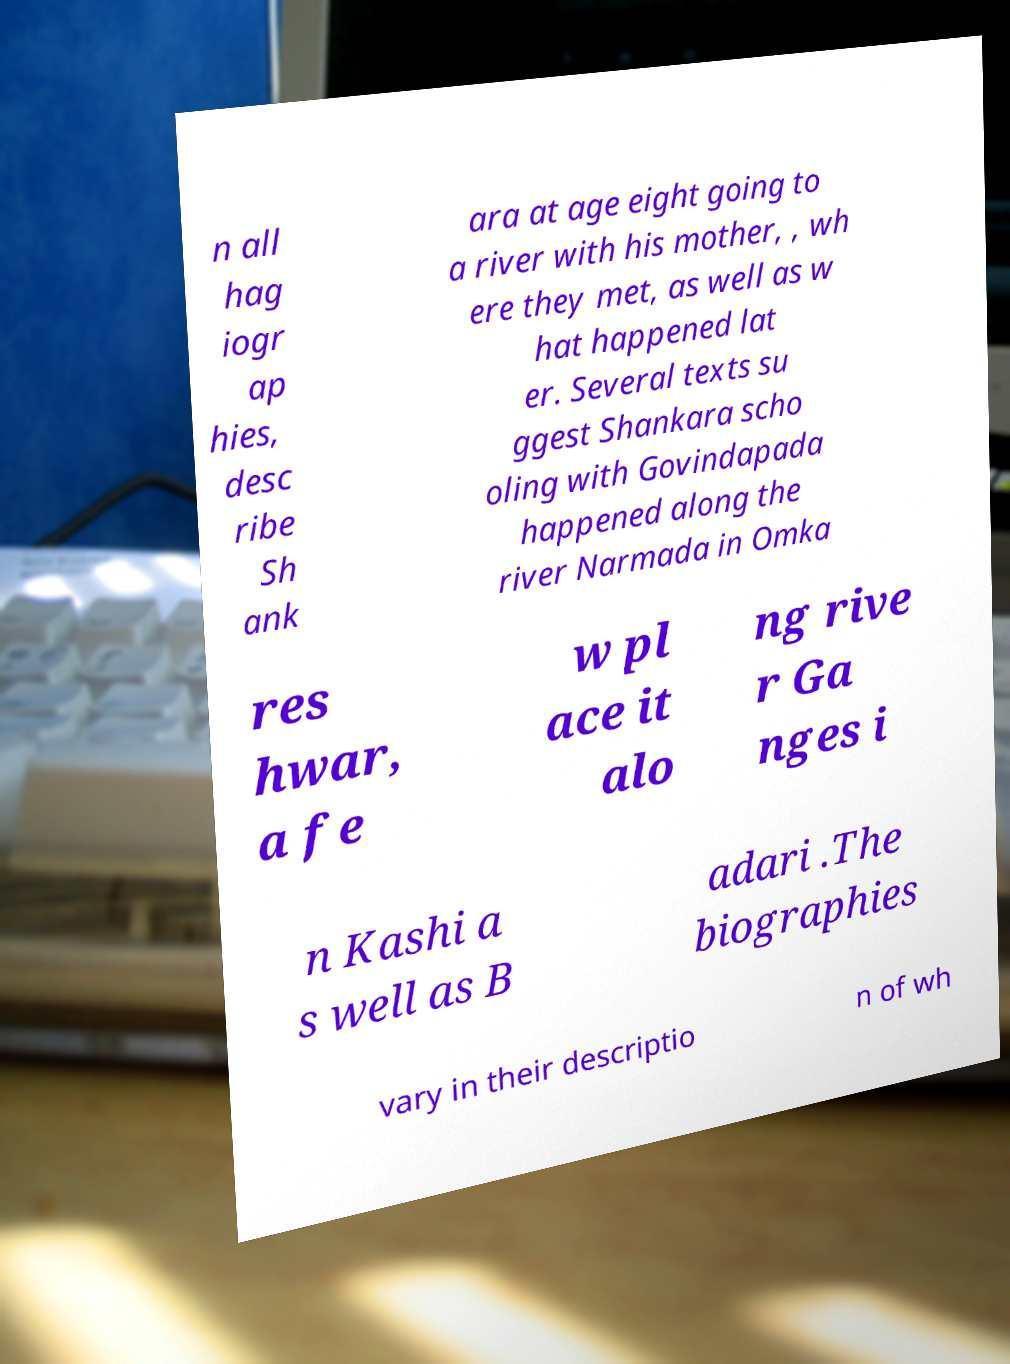For documentation purposes, I need the text within this image transcribed. Could you provide that? n all hag iogr ap hies, desc ribe Sh ank ara at age eight going to a river with his mother, , wh ere they met, as well as w hat happened lat er. Several texts su ggest Shankara scho oling with Govindapada happened along the river Narmada in Omka res hwar, a fe w pl ace it alo ng rive r Ga nges i n Kashi a s well as B adari .The biographies vary in their descriptio n of wh 